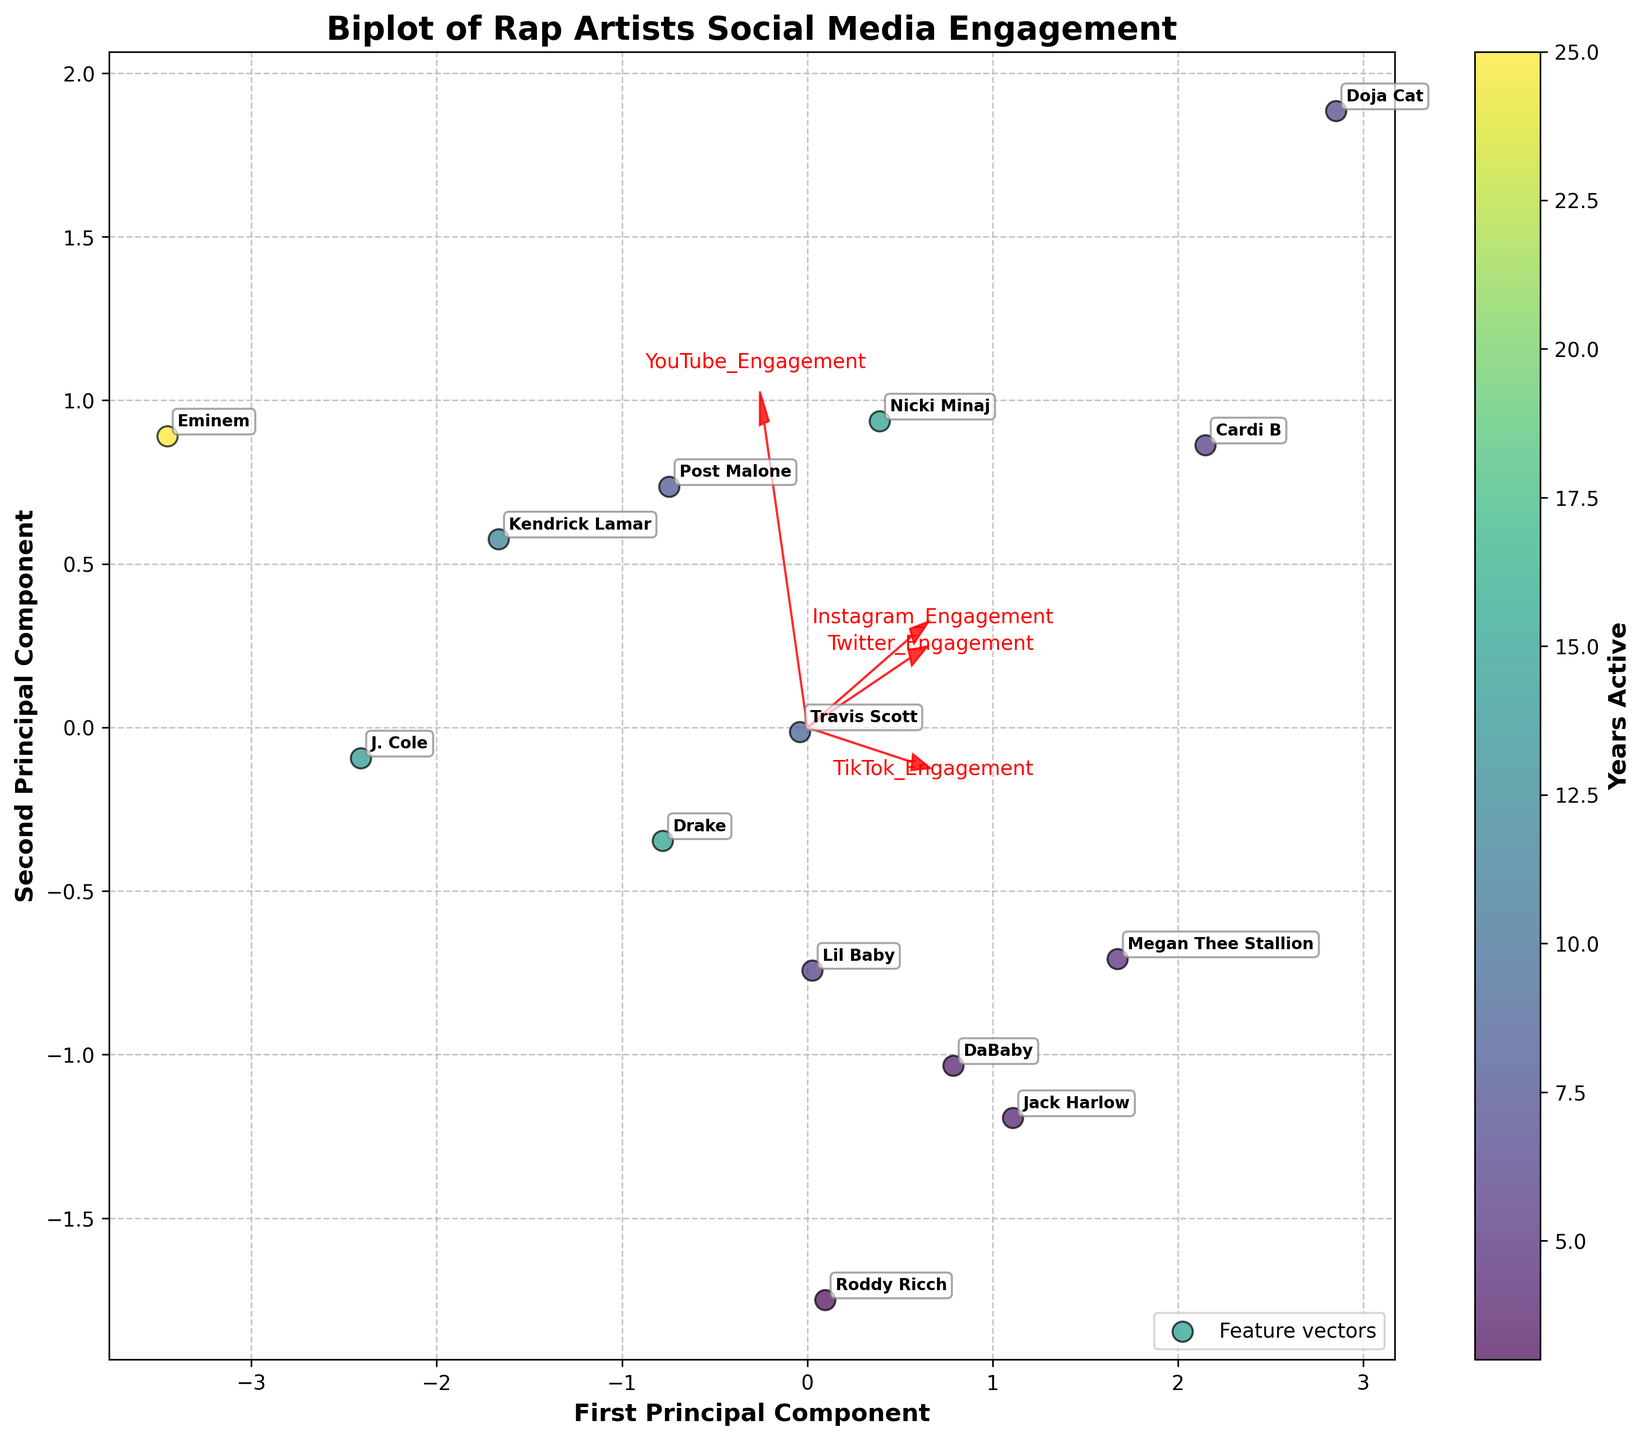Which artist has been active the longest? To determine the artist with the longest active years, look for the highest value in the 'Years Active' color gradient and its corresponding artist label. Eminem has been active for 25 years, which is the longest in the dataset.
Answer: Eminem What is the relationship between Instagram engagement and TikTok engagement based on the arrows in the plot? Look at the direction and length of the feature vectors for Instagram Engagement and TikTok Engagement. Both arrows point in the same general direction and are of similar length, indicating a positive correlation between these two features.
Answer: Positive correlation Which artists are clustered closely together based on their social media engagement? Examine clusters of points that are close to each other in the biplot. Megan Thee Stallion and Cardi B are closely clustered together, suggesting they have similar social media engagement profiles.
Answer: Megan Thee Stallion and Cardi B Which platform shows the greatest variability in engagement among the artists? Assess the length of the arrows representing each platform; the longer the arrow, the greater the variability. TikTok Engagement has the longest arrow, showing the greatest variability among the artists.
Answer: TikTok How do veteran artists (10+ years of activity) compare to newer artists in terms of YouTube engagement? Identify the color gradient that represents veteran artists and compare their positions relative to the YouTube Engagement vector. Veteran artists like Eminem and J. Cole are less associated with high YouTube engagement compared to newer artists like Doja Cat and Cardi B.
Answer: Veteran artists have lower YouTube engagement Which two engagement metrics are most strongly related according to the feature vectors? Look for the pair of arrows pointing in the most similar direction and length. Instagram Engagement and TikTok Engagement arrows are the most similar, indicating a strong relationship.
Answer: Instagram and TikTok Engagement What can be inferred about Drake's engagement on different social media platforms? Find Drake in the biplot and analyze his position relative to the feature vectors. Drake is positioned closer to the Instagram and TikTok vectors, indicating higher engagement on these platforms, while being further from the YouTube and Twitter vectors.
Answer: High on Instagram and TikTok, lower on YouTube and Twitter Is there a relationship between years active and Twitter engagement? Examine the color gradient (representing years active) with respect to the Twitter engagement arrow. There’s no clear directional trend indicating that both new and veteran artists have varied Twitter engagement levels.
Answer: No clear relationship Which artists have the highest TikTok engagement? Analyze the points farthest along the TikTok Engagement vector. Doja Cat and Megan Thee Stallion are positioned closest to this vector.
Answer: Doja Cat and Megan Thee Stallion 